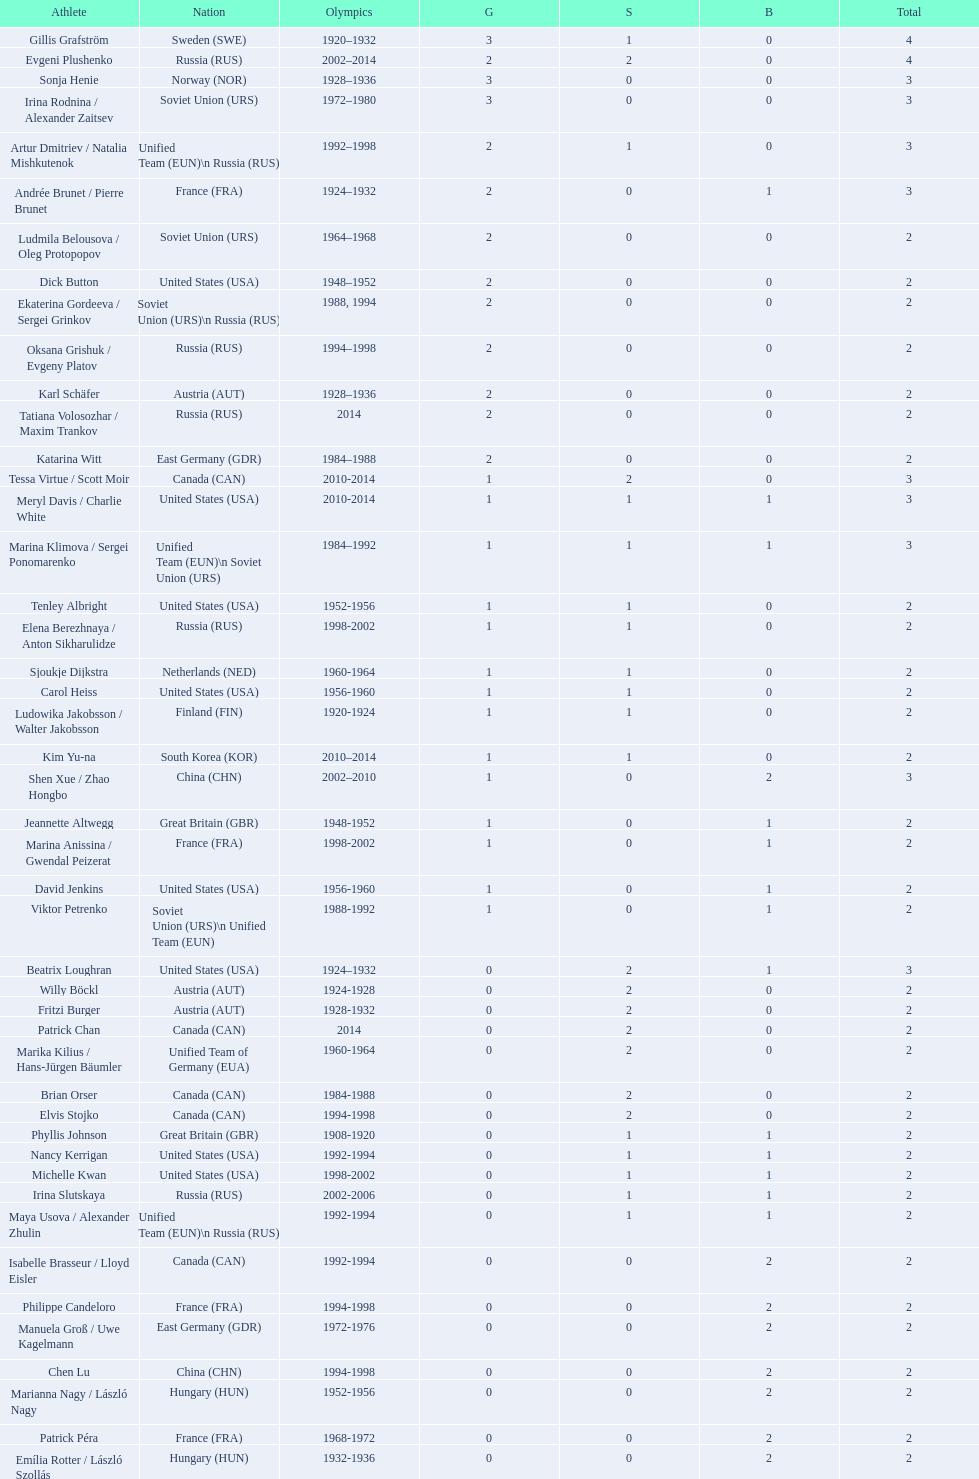In women's figure skating, how many medals has the united states secured overall? 16. 